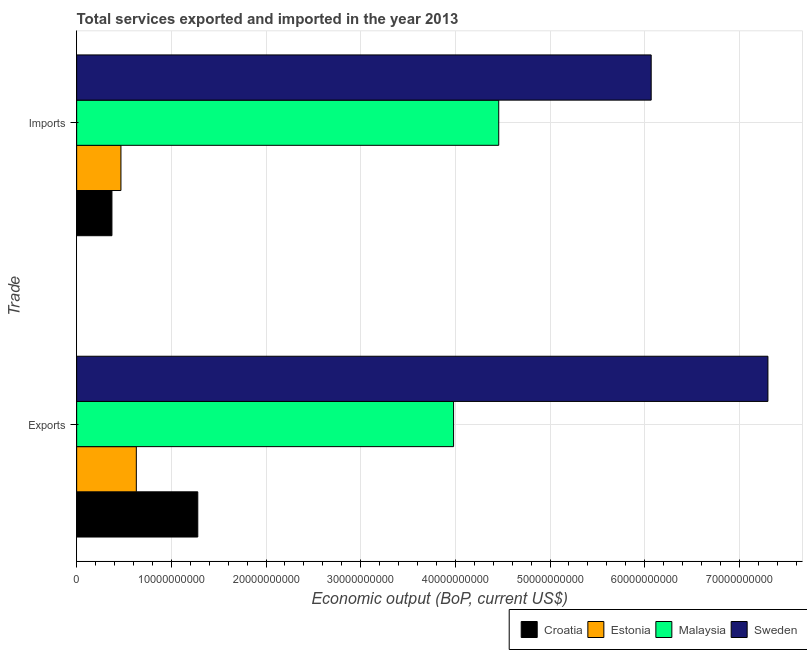How many different coloured bars are there?
Your answer should be very brief. 4. Are the number of bars per tick equal to the number of legend labels?
Your answer should be very brief. Yes. How many bars are there on the 1st tick from the bottom?
Offer a very short reply. 4. What is the label of the 2nd group of bars from the top?
Give a very brief answer. Exports. What is the amount of service imports in Estonia?
Provide a short and direct response. 4.68e+09. Across all countries, what is the maximum amount of service exports?
Offer a terse response. 7.30e+1. Across all countries, what is the minimum amount of service exports?
Provide a succinct answer. 6.30e+09. In which country was the amount of service exports minimum?
Provide a succinct answer. Estonia. What is the total amount of service exports in the graph?
Your answer should be compact. 1.32e+11. What is the difference between the amount of service imports in Sweden and that in Malaysia?
Ensure brevity in your answer.  1.61e+1. What is the difference between the amount of service exports in Malaysia and the amount of service imports in Sweden?
Your answer should be compact. -2.09e+1. What is the average amount of service imports per country?
Make the answer very short. 2.84e+1. What is the difference between the amount of service exports and amount of service imports in Croatia?
Make the answer very short. 9.07e+09. What is the ratio of the amount of service exports in Estonia to that in Croatia?
Offer a very short reply. 0.49. What does the 1st bar from the top in Imports represents?
Provide a short and direct response. Sweden. What does the 2nd bar from the bottom in Exports represents?
Your answer should be compact. Estonia. How many bars are there?
Provide a succinct answer. 8. Are all the bars in the graph horizontal?
Offer a very short reply. Yes. Where does the legend appear in the graph?
Provide a short and direct response. Bottom right. How are the legend labels stacked?
Ensure brevity in your answer.  Horizontal. What is the title of the graph?
Your answer should be very brief. Total services exported and imported in the year 2013. What is the label or title of the X-axis?
Ensure brevity in your answer.  Economic output (BoP, current US$). What is the label or title of the Y-axis?
Offer a terse response. Trade. What is the Economic output (BoP, current US$) of Croatia in Exports?
Provide a succinct answer. 1.28e+1. What is the Economic output (BoP, current US$) of Estonia in Exports?
Give a very brief answer. 6.30e+09. What is the Economic output (BoP, current US$) of Malaysia in Exports?
Your response must be concise. 3.98e+1. What is the Economic output (BoP, current US$) in Sweden in Exports?
Offer a very short reply. 7.30e+1. What is the Economic output (BoP, current US$) in Croatia in Imports?
Offer a terse response. 3.73e+09. What is the Economic output (BoP, current US$) of Estonia in Imports?
Ensure brevity in your answer.  4.68e+09. What is the Economic output (BoP, current US$) of Malaysia in Imports?
Your response must be concise. 4.46e+1. What is the Economic output (BoP, current US$) in Sweden in Imports?
Offer a very short reply. 6.07e+1. Across all Trade, what is the maximum Economic output (BoP, current US$) in Croatia?
Keep it short and to the point. 1.28e+1. Across all Trade, what is the maximum Economic output (BoP, current US$) of Estonia?
Your answer should be compact. 6.30e+09. Across all Trade, what is the maximum Economic output (BoP, current US$) in Malaysia?
Your answer should be compact. 4.46e+1. Across all Trade, what is the maximum Economic output (BoP, current US$) in Sweden?
Your response must be concise. 7.30e+1. Across all Trade, what is the minimum Economic output (BoP, current US$) in Croatia?
Offer a very short reply. 3.73e+09. Across all Trade, what is the minimum Economic output (BoP, current US$) in Estonia?
Offer a terse response. 4.68e+09. Across all Trade, what is the minimum Economic output (BoP, current US$) in Malaysia?
Provide a succinct answer. 3.98e+1. Across all Trade, what is the minimum Economic output (BoP, current US$) of Sweden?
Provide a succinct answer. 6.07e+1. What is the total Economic output (BoP, current US$) in Croatia in the graph?
Offer a very short reply. 1.65e+1. What is the total Economic output (BoP, current US$) in Estonia in the graph?
Provide a short and direct response. 1.10e+1. What is the total Economic output (BoP, current US$) of Malaysia in the graph?
Give a very brief answer. 8.44e+1. What is the total Economic output (BoP, current US$) of Sweden in the graph?
Provide a succinct answer. 1.34e+11. What is the difference between the Economic output (BoP, current US$) of Croatia in Exports and that in Imports?
Offer a very short reply. 9.07e+09. What is the difference between the Economic output (BoP, current US$) in Estonia in Exports and that in Imports?
Your response must be concise. 1.63e+09. What is the difference between the Economic output (BoP, current US$) of Malaysia in Exports and that in Imports?
Provide a succinct answer. -4.77e+09. What is the difference between the Economic output (BoP, current US$) in Sweden in Exports and that in Imports?
Provide a short and direct response. 1.23e+1. What is the difference between the Economic output (BoP, current US$) in Croatia in Exports and the Economic output (BoP, current US$) in Estonia in Imports?
Your answer should be compact. 8.12e+09. What is the difference between the Economic output (BoP, current US$) in Croatia in Exports and the Economic output (BoP, current US$) in Malaysia in Imports?
Keep it short and to the point. -3.18e+1. What is the difference between the Economic output (BoP, current US$) of Croatia in Exports and the Economic output (BoP, current US$) of Sweden in Imports?
Ensure brevity in your answer.  -4.79e+1. What is the difference between the Economic output (BoP, current US$) of Estonia in Exports and the Economic output (BoP, current US$) of Malaysia in Imports?
Offer a terse response. -3.83e+1. What is the difference between the Economic output (BoP, current US$) of Estonia in Exports and the Economic output (BoP, current US$) of Sweden in Imports?
Your answer should be compact. -5.44e+1. What is the difference between the Economic output (BoP, current US$) in Malaysia in Exports and the Economic output (BoP, current US$) in Sweden in Imports?
Provide a short and direct response. -2.09e+1. What is the average Economic output (BoP, current US$) in Croatia per Trade?
Your answer should be very brief. 8.26e+09. What is the average Economic output (BoP, current US$) in Estonia per Trade?
Your response must be concise. 5.49e+09. What is the average Economic output (BoP, current US$) of Malaysia per Trade?
Offer a terse response. 4.22e+1. What is the average Economic output (BoP, current US$) of Sweden per Trade?
Keep it short and to the point. 6.68e+1. What is the difference between the Economic output (BoP, current US$) in Croatia and Economic output (BoP, current US$) in Estonia in Exports?
Your answer should be very brief. 6.49e+09. What is the difference between the Economic output (BoP, current US$) of Croatia and Economic output (BoP, current US$) of Malaysia in Exports?
Your response must be concise. -2.70e+1. What is the difference between the Economic output (BoP, current US$) of Croatia and Economic output (BoP, current US$) of Sweden in Exports?
Your answer should be compact. -6.02e+1. What is the difference between the Economic output (BoP, current US$) of Estonia and Economic output (BoP, current US$) of Malaysia in Exports?
Your response must be concise. -3.35e+1. What is the difference between the Economic output (BoP, current US$) of Estonia and Economic output (BoP, current US$) of Sweden in Exports?
Give a very brief answer. -6.67e+1. What is the difference between the Economic output (BoP, current US$) of Malaysia and Economic output (BoP, current US$) of Sweden in Exports?
Offer a terse response. -3.32e+1. What is the difference between the Economic output (BoP, current US$) in Croatia and Economic output (BoP, current US$) in Estonia in Imports?
Your answer should be very brief. -9.51e+08. What is the difference between the Economic output (BoP, current US$) of Croatia and Economic output (BoP, current US$) of Malaysia in Imports?
Your answer should be compact. -4.09e+1. What is the difference between the Economic output (BoP, current US$) of Croatia and Economic output (BoP, current US$) of Sweden in Imports?
Provide a succinct answer. -5.70e+1. What is the difference between the Economic output (BoP, current US$) in Estonia and Economic output (BoP, current US$) in Malaysia in Imports?
Give a very brief answer. -3.99e+1. What is the difference between the Economic output (BoP, current US$) of Estonia and Economic output (BoP, current US$) of Sweden in Imports?
Provide a succinct answer. -5.60e+1. What is the difference between the Economic output (BoP, current US$) of Malaysia and Economic output (BoP, current US$) of Sweden in Imports?
Ensure brevity in your answer.  -1.61e+1. What is the ratio of the Economic output (BoP, current US$) of Croatia in Exports to that in Imports?
Your answer should be compact. 3.43. What is the ratio of the Economic output (BoP, current US$) in Estonia in Exports to that in Imports?
Provide a succinct answer. 1.35. What is the ratio of the Economic output (BoP, current US$) in Malaysia in Exports to that in Imports?
Offer a terse response. 0.89. What is the ratio of the Economic output (BoP, current US$) of Sweden in Exports to that in Imports?
Your answer should be compact. 1.2. What is the difference between the highest and the second highest Economic output (BoP, current US$) of Croatia?
Ensure brevity in your answer.  9.07e+09. What is the difference between the highest and the second highest Economic output (BoP, current US$) of Estonia?
Offer a very short reply. 1.63e+09. What is the difference between the highest and the second highest Economic output (BoP, current US$) in Malaysia?
Offer a terse response. 4.77e+09. What is the difference between the highest and the second highest Economic output (BoP, current US$) in Sweden?
Ensure brevity in your answer.  1.23e+1. What is the difference between the highest and the lowest Economic output (BoP, current US$) of Croatia?
Your response must be concise. 9.07e+09. What is the difference between the highest and the lowest Economic output (BoP, current US$) in Estonia?
Make the answer very short. 1.63e+09. What is the difference between the highest and the lowest Economic output (BoP, current US$) of Malaysia?
Offer a very short reply. 4.77e+09. What is the difference between the highest and the lowest Economic output (BoP, current US$) in Sweden?
Provide a succinct answer. 1.23e+1. 